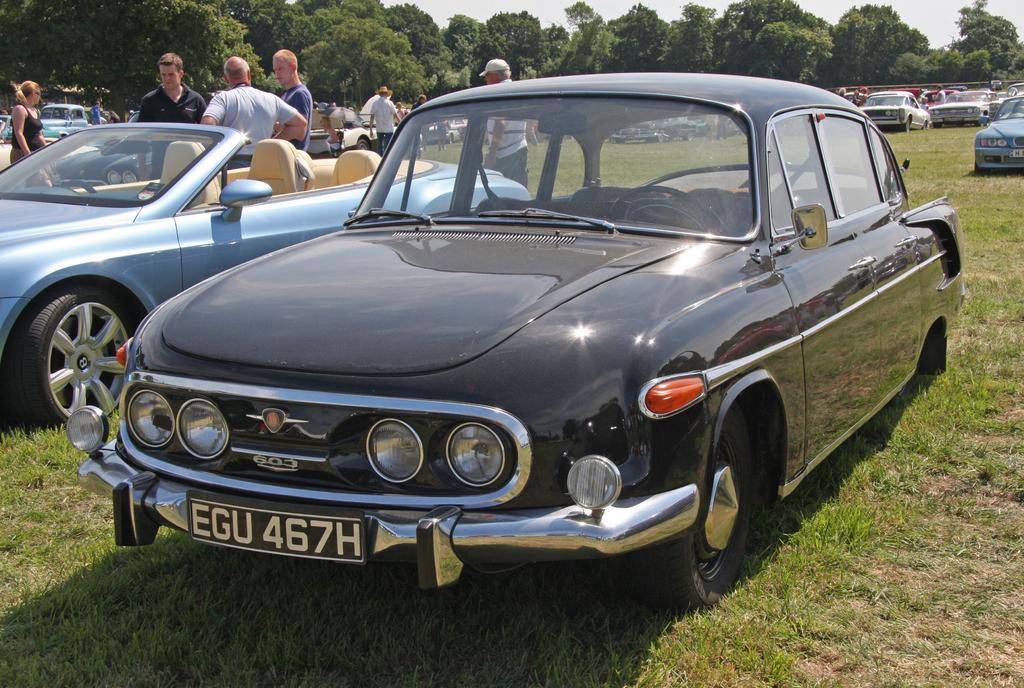In one or two sentences, can you explain what this image depicts? In this picture there is a black car. Beside that we can see sport car. Here we can see group of persons standing near to the car. in the back we can see many people standing near to the vehicles. On the top we can see sky. Here we can see many trees. On the bottom we can see grass. 